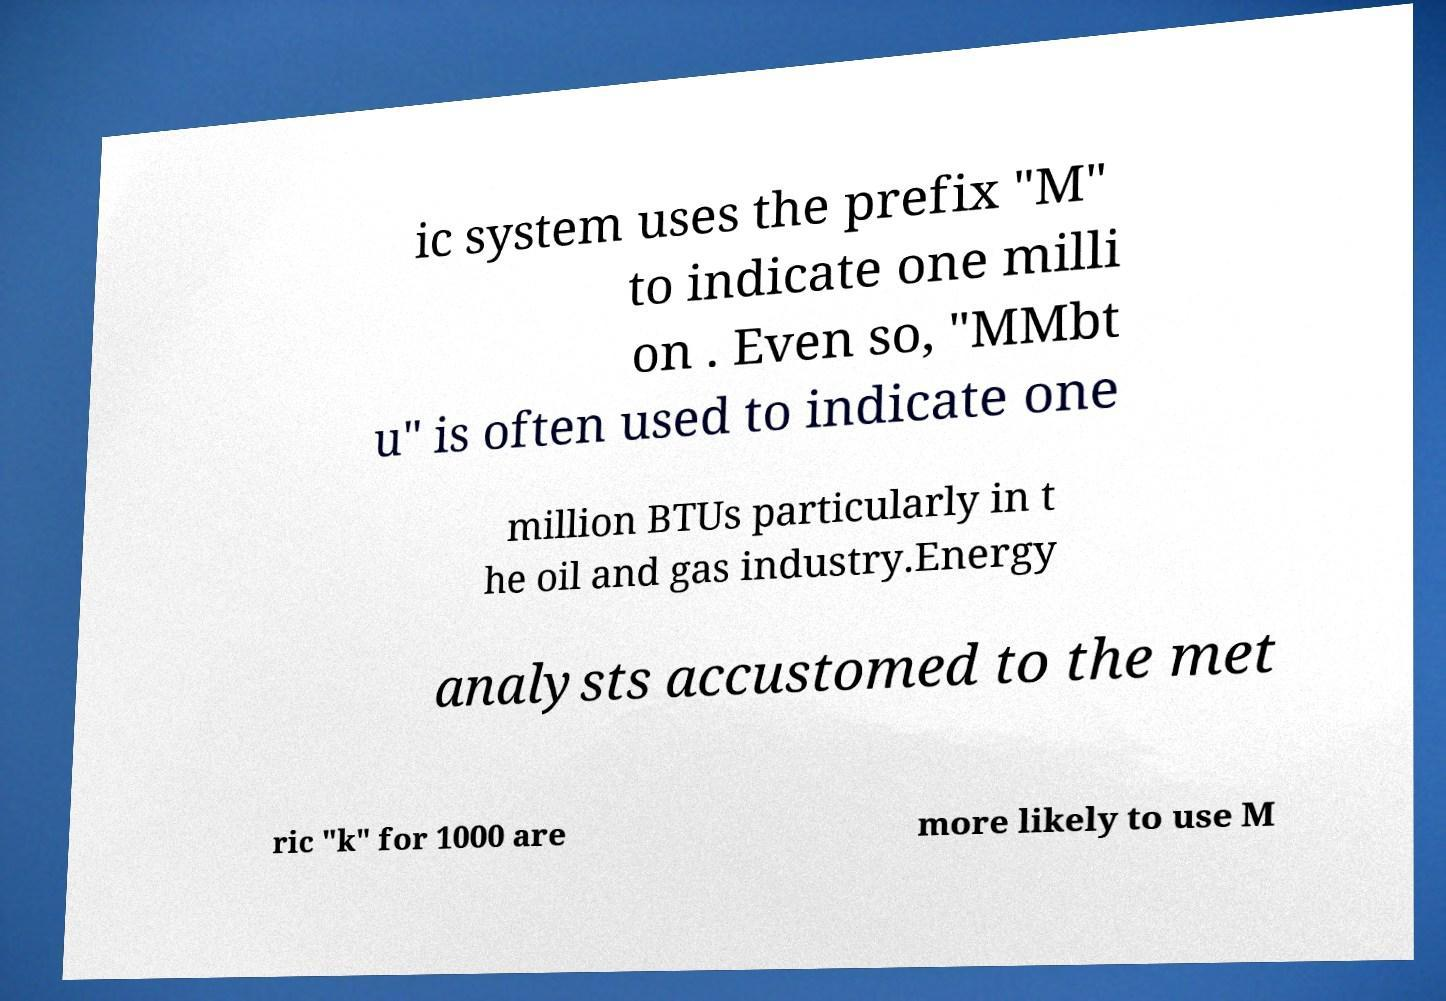Could you extract and type out the text from this image? ic system uses the prefix "M" to indicate one milli on . Even so, "MMbt u" is often used to indicate one million BTUs particularly in t he oil and gas industry.Energy analysts accustomed to the met ric "k" for 1000 are more likely to use M 